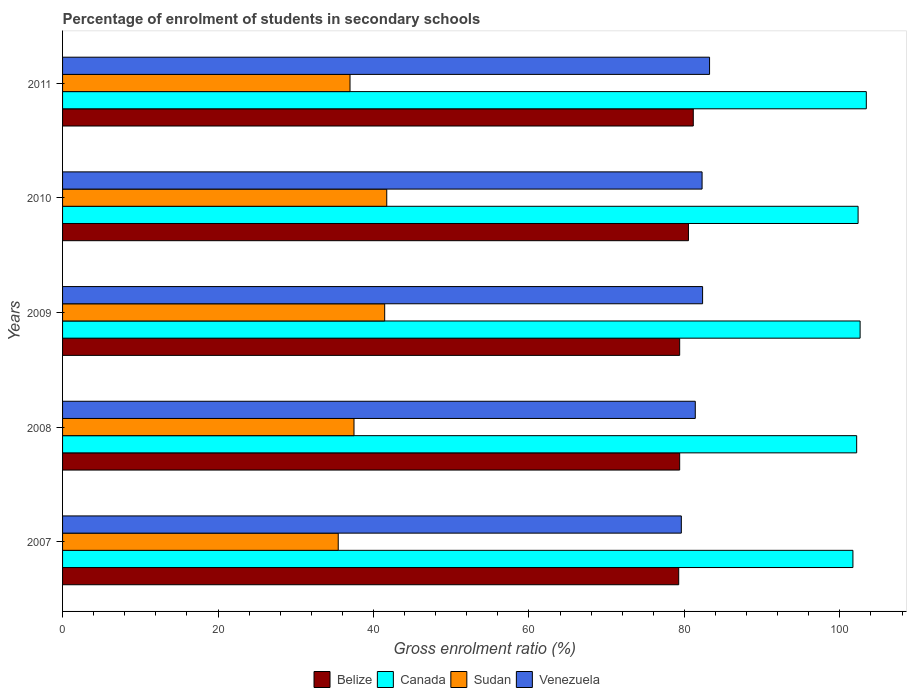How many different coloured bars are there?
Make the answer very short. 4. How many groups of bars are there?
Provide a succinct answer. 5. Are the number of bars per tick equal to the number of legend labels?
Offer a terse response. Yes. How many bars are there on the 1st tick from the top?
Your answer should be compact. 4. In how many cases, is the number of bars for a given year not equal to the number of legend labels?
Your answer should be compact. 0. What is the percentage of students enrolled in secondary schools in Belize in 2011?
Make the answer very short. 81.14. Across all years, what is the maximum percentage of students enrolled in secondary schools in Venezuela?
Your answer should be compact. 83.24. Across all years, what is the minimum percentage of students enrolled in secondary schools in Belize?
Your answer should be very brief. 79.27. In which year was the percentage of students enrolled in secondary schools in Sudan minimum?
Your answer should be very brief. 2007. What is the total percentage of students enrolled in secondary schools in Canada in the graph?
Your answer should be compact. 512.21. What is the difference between the percentage of students enrolled in secondary schools in Belize in 2009 and that in 2011?
Make the answer very short. -1.75. What is the difference between the percentage of students enrolled in secondary schools in Canada in 2010 and the percentage of students enrolled in secondary schools in Venezuela in 2008?
Offer a terse response. 20.95. What is the average percentage of students enrolled in secondary schools in Venezuela per year?
Your answer should be very brief. 81.77. In the year 2009, what is the difference between the percentage of students enrolled in secondary schools in Venezuela and percentage of students enrolled in secondary schools in Canada?
Keep it short and to the point. -20.27. In how many years, is the percentage of students enrolled in secondary schools in Canada greater than 56 %?
Offer a very short reply. 5. What is the ratio of the percentage of students enrolled in secondary schools in Venezuela in 2007 to that in 2008?
Keep it short and to the point. 0.98. Is the difference between the percentage of students enrolled in secondary schools in Venezuela in 2007 and 2009 greater than the difference between the percentage of students enrolled in secondary schools in Canada in 2007 and 2009?
Offer a very short reply. No. What is the difference between the highest and the second highest percentage of students enrolled in secondary schools in Venezuela?
Make the answer very short. 0.9. What is the difference between the highest and the lowest percentage of students enrolled in secondary schools in Sudan?
Give a very brief answer. 6.24. What does the 2nd bar from the top in 2010 represents?
Offer a very short reply. Sudan. What does the 1st bar from the bottom in 2011 represents?
Your answer should be very brief. Belize. Is it the case that in every year, the sum of the percentage of students enrolled in secondary schools in Canada and percentage of students enrolled in secondary schools in Sudan is greater than the percentage of students enrolled in secondary schools in Venezuela?
Keep it short and to the point. Yes. Are all the bars in the graph horizontal?
Give a very brief answer. Yes. How many years are there in the graph?
Provide a succinct answer. 5. Are the values on the major ticks of X-axis written in scientific E-notation?
Offer a terse response. No. Where does the legend appear in the graph?
Your answer should be compact. Bottom center. How many legend labels are there?
Your answer should be very brief. 4. How are the legend labels stacked?
Your response must be concise. Horizontal. What is the title of the graph?
Your response must be concise. Percentage of enrolment of students in secondary schools. What is the label or title of the X-axis?
Your response must be concise. Gross enrolment ratio (%). What is the Gross enrolment ratio (%) in Belize in 2007?
Your answer should be compact. 79.27. What is the Gross enrolment ratio (%) in Canada in 2007?
Your answer should be very brief. 101.68. What is the Gross enrolment ratio (%) in Sudan in 2007?
Your answer should be very brief. 35.47. What is the Gross enrolment ratio (%) of Venezuela in 2007?
Make the answer very short. 79.61. What is the Gross enrolment ratio (%) in Belize in 2008?
Give a very brief answer. 79.39. What is the Gross enrolment ratio (%) in Canada in 2008?
Give a very brief answer. 102.16. What is the Gross enrolment ratio (%) in Sudan in 2008?
Your response must be concise. 37.49. What is the Gross enrolment ratio (%) of Venezuela in 2008?
Your answer should be very brief. 81.4. What is the Gross enrolment ratio (%) of Belize in 2009?
Make the answer very short. 79.39. What is the Gross enrolment ratio (%) in Canada in 2009?
Provide a short and direct response. 102.61. What is the Gross enrolment ratio (%) in Sudan in 2009?
Provide a short and direct response. 41.44. What is the Gross enrolment ratio (%) in Venezuela in 2009?
Offer a very short reply. 82.34. What is the Gross enrolment ratio (%) in Belize in 2010?
Offer a very short reply. 80.52. What is the Gross enrolment ratio (%) in Canada in 2010?
Ensure brevity in your answer.  102.35. What is the Gross enrolment ratio (%) in Sudan in 2010?
Ensure brevity in your answer.  41.71. What is the Gross enrolment ratio (%) in Venezuela in 2010?
Provide a succinct answer. 82.28. What is the Gross enrolment ratio (%) of Belize in 2011?
Provide a short and direct response. 81.14. What is the Gross enrolment ratio (%) in Canada in 2011?
Ensure brevity in your answer.  103.4. What is the Gross enrolment ratio (%) in Sudan in 2011?
Provide a short and direct response. 36.98. What is the Gross enrolment ratio (%) in Venezuela in 2011?
Your answer should be very brief. 83.24. Across all years, what is the maximum Gross enrolment ratio (%) of Belize?
Offer a very short reply. 81.14. Across all years, what is the maximum Gross enrolment ratio (%) of Canada?
Offer a terse response. 103.4. Across all years, what is the maximum Gross enrolment ratio (%) of Sudan?
Your response must be concise. 41.71. Across all years, what is the maximum Gross enrolment ratio (%) of Venezuela?
Your answer should be very brief. 83.24. Across all years, what is the minimum Gross enrolment ratio (%) in Belize?
Provide a succinct answer. 79.27. Across all years, what is the minimum Gross enrolment ratio (%) of Canada?
Provide a succinct answer. 101.68. Across all years, what is the minimum Gross enrolment ratio (%) in Sudan?
Provide a short and direct response. 35.47. Across all years, what is the minimum Gross enrolment ratio (%) in Venezuela?
Give a very brief answer. 79.61. What is the total Gross enrolment ratio (%) of Belize in the graph?
Ensure brevity in your answer.  399.72. What is the total Gross enrolment ratio (%) in Canada in the graph?
Provide a succinct answer. 512.21. What is the total Gross enrolment ratio (%) of Sudan in the graph?
Your answer should be very brief. 193.09. What is the total Gross enrolment ratio (%) in Venezuela in the graph?
Offer a very short reply. 408.86. What is the difference between the Gross enrolment ratio (%) of Belize in 2007 and that in 2008?
Make the answer very short. -0.12. What is the difference between the Gross enrolment ratio (%) in Canada in 2007 and that in 2008?
Provide a succinct answer. -0.48. What is the difference between the Gross enrolment ratio (%) of Sudan in 2007 and that in 2008?
Your answer should be very brief. -2.03. What is the difference between the Gross enrolment ratio (%) of Venezuela in 2007 and that in 2008?
Offer a terse response. -1.8. What is the difference between the Gross enrolment ratio (%) in Belize in 2007 and that in 2009?
Keep it short and to the point. -0.12. What is the difference between the Gross enrolment ratio (%) of Canada in 2007 and that in 2009?
Offer a terse response. -0.93. What is the difference between the Gross enrolment ratio (%) of Sudan in 2007 and that in 2009?
Ensure brevity in your answer.  -5.98. What is the difference between the Gross enrolment ratio (%) of Venezuela in 2007 and that in 2009?
Offer a very short reply. -2.74. What is the difference between the Gross enrolment ratio (%) of Belize in 2007 and that in 2010?
Your answer should be compact. -1.25. What is the difference between the Gross enrolment ratio (%) of Canada in 2007 and that in 2010?
Your answer should be compact. -0.67. What is the difference between the Gross enrolment ratio (%) of Sudan in 2007 and that in 2010?
Give a very brief answer. -6.24. What is the difference between the Gross enrolment ratio (%) of Venezuela in 2007 and that in 2010?
Your response must be concise. -2.67. What is the difference between the Gross enrolment ratio (%) in Belize in 2007 and that in 2011?
Your response must be concise. -1.88. What is the difference between the Gross enrolment ratio (%) in Canada in 2007 and that in 2011?
Offer a terse response. -1.72. What is the difference between the Gross enrolment ratio (%) of Sudan in 2007 and that in 2011?
Provide a short and direct response. -1.52. What is the difference between the Gross enrolment ratio (%) in Venezuela in 2007 and that in 2011?
Your answer should be compact. -3.63. What is the difference between the Gross enrolment ratio (%) in Belize in 2008 and that in 2009?
Ensure brevity in your answer.  0. What is the difference between the Gross enrolment ratio (%) in Canada in 2008 and that in 2009?
Give a very brief answer. -0.44. What is the difference between the Gross enrolment ratio (%) in Sudan in 2008 and that in 2009?
Offer a terse response. -3.95. What is the difference between the Gross enrolment ratio (%) of Venezuela in 2008 and that in 2009?
Provide a short and direct response. -0.94. What is the difference between the Gross enrolment ratio (%) of Belize in 2008 and that in 2010?
Provide a succinct answer. -1.13. What is the difference between the Gross enrolment ratio (%) of Canada in 2008 and that in 2010?
Provide a succinct answer. -0.18. What is the difference between the Gross enrolment ratio (%) in Sudan in 2008 and that in 2010?
Provide a short and direct response. -4.21. What is the difference between the Gross enrolment ratio (%) in Venezuela in 2008 and that in 2010?
Your answer should be very brief. -0.87. What is the difference between the Gross enrolment ratio (%) in Belize in 2008 and that in 2011?
Ensure brevity in your answer.  -1.75. What is the difference between the Gross enrolment ratio (%) of Canada in 2008 and that in 2011?
Your response must be concise. -1.24. What is the difference between the Gross enrolment ratio (%) of Sudan in 2008 and that in 2011?
Your answer should be compact. 0.51. What is the difference between the Gross enrolment ratio (%) of Venezuela in 2008 and that in 2011?
Provide a succinct answer. -1.84. What is the difference between the Gross enrolment ratio (%) in Belize in 2009 and that in 2010?
Your answer should be very brief. -1.13. What is the difference between the Gross enrolment ratio (%) of Canada in 2009 and that in 2010?
Your answer should be compact. 0.26. What is the difference between the Gross enrolment ratio (%) in Sudan in 2009 and that in 2010?
Provide a short and direct response. -0.27. What is the difference between the Gross enrolment ratio (%) of Venezuela in 2009 and that in 2010?
Keep it short and to the point. 0.07. What is the difference between the Gross enrolment ratio (%) in Belize in 2009 and that in 2011?
Your answer should be compact. -1.75. What is the difference between the Gross enrolment ratio (%) of Canada in 2009 and that in 2011?
Ensure brevity in your answer.  -0.8. What is the difference between the Gross enrolment ratio (%) of Sudan in 2009 and that in 2011?
Give a very brief answer. 4.46. What is the difference between the Gross enrolment ratio (%) in Venezuela in 2009 and that in 2011?
Provide a succinct answer. -0.9. What is the difference between the Gross enrolment ratio (%) of Belize in 2010 and that in 2011?
Offer a very short reply. -0.62. What is the difference between the Gross enrolment ratio (%) of Canada in 2010 and that in 2011?
Offer a very short reply. -1.06. What is the difference between the Gross enrolment ratio (%) in Sudan in 2010 and that in 2011?
Give a very brief answer. 4.73. What is the difference between the Gross enrolment ratio (%) in Venezuela in 2010 and that in 2011?
Offer a terse response. -0.96. What is the difference between the Gross enrolment ratio (%) in Belize in 2007 and the Gross enrolment ratio (%) in Canada in 2008?
Make the answer very short. -22.9. What is the difference between the Gross enrolment ratio (%) of Belize in 2007 and the Gross enrolment ratio (%) of Sudan in 2008?
Your answer should be compact. 41.77. What is the difference between the Gross enrolment ratio (%) of Belize in 2007 and the Gross enrolment ratio (%) of Venezuela in 2008?
Offer a terse response. -2.13. What is the difference between the Gross enrolment ratio (%) in Canada in 2007 and the Gross enrolment ratio (%) in Sudan in 2008?
Give a very brief answer. 64.19. What is the difference between the Gross enrolment ratio (%) in Canada in 2007 and the Gross enrolment ratio (%) in Venezuela in 2008?
Your answer should be very brief. 20.28. What is the difference between the Gross enrolment ratio (%) of Sudan in 2007 and the Gross enrolment ratio (%) of Venezuela in 2008?
Ensure brevity in your answer.  -45.94. What is the difference between the Gross enrolment ratio (%) in Belize in 2007 and the Gross enrolment ratio (%) in Canada in 2009?
Offer a terse response. -23.34. What is the difference between the Gross enrolment ratio (%) in Belize in 2007 and the Gross enrolment ratio (%) in Sudan in 2009?
Keep it short and to the point. 37.83. What is the difference between the Gross enrolment ratio (%) of Belize in 2007 and the Gross enrolment ratio (%) of Venezuela in 2009?
Provide a short and direct response. -3.07. What is the difference between the Gross enrolment ratio (%) in Canada in 2007 and the Gross enrolment ratio (%) in Sudan in 2009?
Your answer should be compact. 60.24. What is the difference between the Gross enrolment ratio (%) of Canada in 2007 and the Gross enrolment ratio (%) of Venezuela in 2009?
Offer a very short reply. 19.34. What is the difference between the Gross enrolment ratio (%) of Sudan in 2007 and the Gross enrolment ratio (%) of Venezuela in 2009?
Your response must be concise. -46.88. What is the difference between the Gross enrolment ratio (%) in Belize in 2007 and the Gross enrolment ratio (%) in Canada in 2010?
Make the answer very short. -23.08. What is the difference between the Gross enrolment ratio (%) of Belize in 2007 and the Gross enrolment ratio (%) of Sudan in 2010?
Your response must be concise. 37.56. What is the difference between the Gross enrolment ratio (%) in Belize in 2007 and the Gross enrolment ratio (%) in Venezuela in 2010?
Your answer should be very brief. -3.01. What is the difference between the Gross enrolment ratio (%) in Canada in 2007 and the Gross enrolment ratio (%) in Sudan in 2010?
Your answer should be very brief. 59.97. What is the difference between the Gross enrolment ratio (%) in Canada in 2007 and the Gross enrolment ratio (%) in Venezuela in 2010?
Offer a very short reply. 19.41. What is the difference between the Gross enrolment ratio (%) of Sudan in 2007 and the Gross enrolment ratio (%) of Venezuela in 2010?
Your response must be concise. -46.81. What is the difference between the Gross enrolment ratio (%) of Belize in 2007 and the Gross enrolment ratio (%) of Canada in 2011?
Offer a terse response. -24.14. What is the difference between the Gross enrolment ratio (%) of Belize in 2007 and the Gross enrolment ratio (%) of Sudan in 2011?
Give a very brief answer. 42.29. What is the difference between the Gross enrolment ratio (%) of Belize in 2007 and the Gross enrolment ratio (%) of Venezuela in 2011?
Ensure brevity in your answer.  -3.97. What is the difference between the Gross enrolment ratio (%) of Canada in 2007 and the Gross enrolment ratio (%) of Sudan in 2011?
Offer a terse response. 64.7. What is the difference between the Gross enrolment ratio (%) of Canada in 2007 and the Gross enrolment ratio (%) of Venezuela in 2011?
Give a very brief answer. 18.44. What is the difference between the Gross enrolment ratio (%) of Sudan in 2007 and the Gross enrolment ratio (%) of Venezuela in 2011?
Offer a terse response. -47.77. What is the difference between the Gross enrolment ratio (%) of Belize in 2008 and the Gross enrolment ratio (%) of Canada in 2009?
Your response must be concise. -23.21. What is the difference between the Gross enrolment ratio (%) of Belize in 2008 and the Gross enrolment ratio (%) of Sudan in 2009?
Ensure brevity in your answer.  37.95. What is the difference between the Gross enrolment ratio (%) of Belize in 2008 and the Gross enrolment ratio (%) of Venezuela in 2009?
Offer a very short reply. -2.95. What is the difference between the Gross enrolment ratio (%) in Canada in 2008 and the Gross enrolment ratio (%) in Sudan in 2009?
Your answer should be very brief. 60.72. What is the difference between the Gross enrolment ratio (%) of Canada in 2008 and the Gross enrolment ratio (%) of Venezuela in 2009?
Your response must be concise. 19.82. What is the difference between the Gross enrolment ratio (%) in Sudan in 2008 and the Gross enrolment ratio (%) in Venezuela in 2009?
Give a very brief answer. -44.85. What is the difference between the Gross enrolment ratio (%) in Belize in 2008 and the Gross enrolment ratio (%) in Canada in 2010?
Your response must be concise. -22.95. What is the difference between the Gross enrolment ratio (%) in Belize in 2008 and the Gross enrolment ratio (%) in Sudan in 2010?
Give a very brief answer. 37.69. What is the difference between the Gross enrolment ratio (%) in Belize in 2008 and the Gross enrolment ratio (%) in Venezuela in 2010?
Your answer should be compact. -2.88. What is the difference between the Gross enrolment ratio (%) of Canada in 2008 and the Gross enrolment ratio (%) of Sudan in 2010?
Give a very brief answer. 60.46. What is the difference between the Gross enrolment ratio (%) in Canada in 2008 and the Gross enrolment ratio (%) in Venezuela in 2010?
Your response must be concise. 19.89. What is the difference between the Gross enrolment ratio (%) in Sudan in 2008 and the Gross enrolment ratio (%) in Venezuela in 2010?
Your response must be concise. -44.78. What is the difference between the Gross enrolment ratio (%) of Belize in 2008 and the Gross enrolment ratio (%) of Canada in 2011?
Offer a terse response. -24.01. What is the difference between the Gross enrolment ratio (%) of Belize in 2008 and the Gross enrolment ratio (%) of Sudan in 2011?
Your answer should be compact. 42.41. What is the difference between the Gross enrolment ratio (%) of Belize in 2008 and the Gross enrolment ratio (%) of Venezuela in 2011?
Provide a short and direct response. -3.84. What is the difference between the Gross enrolment ratio (%) in Canada in 2008 and the Gross enrolment ratio (%) in Sudan in 2011?
Your answer should be very brief. 65.18. What is the difference between the Gross enrolment ratio (%) in Canada in 2008 and the Gross enrolment ratio (%) in Venezuela in 2011?
Provide a succinct answer. 18.93. What is the difference between the Gross enrolment ratio (%) of Sudan in 2008 and the Gross enrolment ratio (%) of Venezuela in 2011?
Keep it short and to the point. -45.74. What is the difference between the Gross enrolment ratio (%) of Belize in 2009 and the Gross enrolment ratio (%) of Canada in 2010?
Make the answer very short. -22.95. What is the difference between the Gross enrolment ratio (%) in Belize in 2009 and the Gross enrolment ratio (%) in Sudan in 2010?
Make the answer very short. 37.69. What is the difference between the Gross enrolment ratio (%) in Belize in 2009 and the Gross enrolment ratio (%) in Venezuela in 2010?
Give a very brief answer. -2.88. What is the difference between the Gross enrolment ratio (%) in Canada in 2009 and the Gross enrolment ratio (%) in Sudan in 2010?
Your answer should be very brief. 60.9. What is the difference between the Gross enrolment ratio (%) in Canada in 2009 and the Gross enrolment ratio (%) in Venezuela in 2010?
Your answer should be very brief. 20.33. What is the difference between the Gross enrolment ratio (%) of Sudan in 2009 and the Gross enrolment ratio (%) of Venezuela in 2010?
Provide a short and direct response. -40.83. What is the difference between the Gross enrolment ratio (%) of Belize in 2009 and the Gross enrolment ratio (%) of Canada in 2011?
Keep it short and to the point. -24.01. What is the difference between the Gross enrolment ratio (%) in Belize in 2009 and the Gross enrolment ratio (%) in Sudan in 2011?
Your answer should be compact. 42.41. What is the difference between the Gross enrolment ratio (%) of Belize in 2009 and the Gross enrolment ratio (%) of Venezuela in 2011?
Ensure brevity in your answer.  -3.85. What is the difference between the Gross enrolment ratio (%) in Canada in 2009 and the Gross enrolment ratio (%) in Sudan in 2011?
Your answer should be compact. 65.63. What is the difference between the Gross enrolment ratio (%) of Canada in 2009 and the Gross enrolment ratio (%) of Venezuela in 2011?
Keep it short and to the point. 19.37. What is the difference between the Gross enrolment ratio (%) of Sudan in 2009 and the Gross enrolment ratio (%) of Venezuela in 2011?
Provide a succinct answer. -41.8. What is the difference between the Gross enrolment ratio (%) in Belize in 2010 and the Gross enrolment ratio (%) in Canada in 2011?
Offer a terse response. -22.88. What is the difference between the Gross enrolment ratio (%) of Belize in 2010 and the Gross enrolment ratio (%) of Sudan in 2011?
Offer a terse response. 43.54. What is the difference between the Gross enrolment ratio (%) of Belize in 2010 and the Gross enrolment ratio (%) of Venezuela in 2011?
Your response must be concise. -2.72. What is the difference between the Gross enrolment ratio (%) in Canada in 2010 and the Gross enrolment ratio (%) in Sudan in 2011?
Keep it short and to the point. 65.37. What is the difference between the Gross enrolment ratio (%) in Canada in 2010 and the Gross enrolment ratio (%) in Venezuela in 2011?
Ensure brevity in your answer.  19.11. What is the difference between the Gross enrolment ratio (%) of Sudan in 2010 and the Gross enrolment ratio (%) of Venezuela in 2011?
Provide a succinct answer. -41.53. What is the average Gross enrolment ratio (%) in Belize per year?
Keep it short and to the point. 79.94. What is the average Gross enrolment ratio (%) in Canada per year?
Provide a succinct answer. 102.44. What is the average Gross enrolment ratio (%) of Sudan per year?
Keep it short and to the point. 38.62. What is the average Gross enrolment ratio (%) of Venezuela per year?
Offer a very short reply. 81.77. In the year 2007, what is the difference between the Gross enrolment ratio (%) of Belize and Gross enrolment ratio (%) of Canada?
Give a very brief answer. -22.41. In the year 2007, what is the difference between the Gross enrolment ratio (%) in Belize and Gross enrolment ratio (%) in Sudan?
Your response must be concise. 43.8. In the year 2007, what is the difference between the Gross enrolment ratio (%) in Belize and Gross enrolment ratio (%) in Venezuela?
Your answer should be compact. -0.34. In the year 2007, what is the difference between the Gross enrolment ratio (%) of Canada and Gross enrolment ratio (%) of Sudan?
Your response must be concise. 66.22. In the year 2007, what is the difference between the Gross enrolment ratio (%) of Canada and Gross enrolment ratio (%) of Venezuela?
Keep it short and to the point. 22.08. In the year 2007, what is the difference between the Gross enrolment ratio (%) in Sudan and Gross enrolment ratio (%) in Venezuela?
Your answer should be compact. -44.14. In the year 2008, what is the difference between the Gross enrolment ratio (%) of Belize and Gross enrolment ratio (%) of Canada?
Your answer should be very brief. -22.77. In the year 2008, what is the difference between the Gross enrolment ratio (%) of Belize and Gross enrolment ratio (%) of Sudan?
Offer a very short reply. 41.9. In the year 2008, what is the difference between the Gross enrolment ratio (%) of Belize and Gross enrolment ratio (%) of Venezuela?
Offer a terse response. -2.01. In the year 2008, what is the difference between the Gross enrolment ratio (%) of Canada and Gross enrolment ratio (%) of Sudan?
Keep it short and to the point. 64.67. In the year 2008, what is the difference between the Gross enrolment ratio (%) in Canada and Gross enrolment ratio (%) in Venezuela?
Give a very brief answer. 20.76. In the year 2008, what is the difference between the Gross enrolment ratio (%) in Sudan and Gross enrolment ratio (%) in Venezuela?
Offer a very short reply. -43.91. In the year 2009, what is the difference between the Gross enrolment ratio (%) in Belize and Gross enrolment ratio (%) in Canada?
Your answer should be compact. -23.21. In the year 2009, what is the difference between the Gross enrolment ratio (%) of Belize and Gross enrolment ratio (%) of Sudan?
Offer a terse response. 37.95. In the year 2009, what is the difference between the Gross enrolment ratio (%) of Belize and Gross enrolment ratio (%) of Venezuela?
Keep it short and to the point. -2.95. In the year 2009, what is the difference between the Gross enrolment ratio (%) in Canada and Gross enrolment ratio (%) in Sudan?
Offer a very short reply. 61.17. In the year 2009, what is the difference between the Gross enrolment ratio (%) in Canada and Gross enrolment ratio (%) in Venezuela?
Provide a short and direct response. 20.27. In the year 2009, what is the difference between the Gross enrolment ratio (%) of Sudan and Gross enrolment ratio (%) of Venezuela?
Provide a short and direct response. -40.9. In the year 2010, what is the difference between the Gross enrolment ratio (%) of Belize and Gross enrolment ratio (%) of Canada?
Your answer should be very brief. -21.83. In the year 2010, what is the difference between the Gross enrolment ratio (%) of Belize and Gross enrolment ratio (%) of Sudan?
Provide a succinct answer. 38.81. In the year 2010, what is the difference between the Gross enrolment ratio (%) in Belize and Gross enrolment ratio (%) in Venezuela?
Provide a succinct answer. -1.75. In the year 2010, what is the difference between the Gross enrolment ratio (%) of Canada and Gross enrolment ratio (%) of Sudan?
Make the answer very short. 60.64. In the year 2010, what is the difference between the Gross enrolment ratio (%) in Canada and Gross enrolment ratio (%) in Venezuela?
Your answer should be compact. 20.07. In the year 2010, what is the difference between the Gross enrolment ratio (%) of Sudan and Gross enrolment ratio (%) of Venezuela?
Offer a terse response. -40.57. In the year 2011, what is the difference between the Gross enrolment ratio (%) of Belize and Gross enrolment ratio (%) of Canada?
Your answer should be very brief. -22.26. In the year 2011, what is the difference between the Gross enrolment ratio (%) of Belize and Gross enrolment ratio (%) of Sudan?
Your answer should be very brief. 44.16. In the year 2011, what is the difference between the Gross enrolment ratio (%) of Belize and Gross enrolment ratio (%) of Venezuela?
Provide a short and direct response. -2.09. In the year 2011, what is the difference between the Gross enrolment ratio (%) of Canada and Gross enrolment ratio (%) of Sudan?
Offer a terse response. 66.42. In the year 2011, what is the difference between the Gross enrolment ratio (%) of Canada and Gross enrolment ratio (%) of Venezuela?
Your answer should be compact. 20.17. In the year 2011, what is the difference between the Gross enrolment ratio (%) of Sudan and Gross enrolment ratio (%) of Venezuela?
Keep it short and to the point. -46.26. What is the ratio of the Gross enrolment ratio (%) of Sudan in 2007 to that in 2008?
Your answer should be very brief. 0.95. What is the ratio of the Gross enrolment ratio (%) of Venezuela in 2007 to that in 2008?
Give a very brief answer. 0.98. What is the ratio of the Gross enrolment ratio (%) in Belize in 2007 to that in 2009?
Provide a succinct answer. 1. What is the ratio of the Gross enrolment ratio (%) in Sudan in 2007 to that in 2009?
Ensure brevity in your answer.  0.86. What is the ratio of the Gross enrolment ratio (%) in Venezuela in 2007 to that in 2009?
Provide a succinct answer. 0.97. What is the ratio of the Gross enrolment ratio (%) of Belize in 2007 to that in 2010?
Provide a succinct answer. 0.98. What is the ratio of the Gross enrolment ratio (%) in Canada in 2007 to that in 2010?
Ensure brevity in your answer.  0.99. What is the ratio of the Gross enrolment ratio (%) of Sudan in 2007 to that in 2010?
Keep it short and to the point. 0.85. What is the ratio of the Gross enrolment ratio (%) of Venezuela in 2007 to that in 2010?
Ensure brevity in your answer.  0.97. What is the ratio of the Gross enrolment ratio (%) in Belize in 2007 to that in 2011?
Your response must be concise. 0.98. What is the ratio of the Gross enrolment ratio (%) in Canada in 2007 to that in 2011?
Your response must be concise. 0.98. What is the ratio of the Gross enrolment ratio (%) in Sudan in 2007 to that in 2011?
Keep it short and to the point. 0.96. What is the ratio of the Gross enrolment ratio (%) in Venezuela in 2007 to that in 2011?
Give a very brief answer. 0.96. What is the ratio of the Gross enrolment ratio (%) of Belize in 2008 to that in 2009?
Make the answer very short. 1. What is the ratio of the Gross enrolment ratio (%) of Sudan in 2008 to that in 2009?
Provide a short and direct response. 0.9. What is the ratio of the Gross enrolment ratio (%) in Belize in 2008 to that in 2010?
Provide a short and direct response. 0.99. What is the ratio of the Gross enrolment ratio (%) of Sudan in 2008 to that in 2010?
Your answer should be compact. 0.9. What is the ratio of the Gross enrolment ratio (%) of Venezuela in 2008 to that in 2010?
Your response must be concise. 0.99. What is the ratio of the Gross enrolment ratio (%) in Belize in 2008 to that in 2011?
Your response must be concise. 0.98. What is the ratio of the Gross enrolment ratio (%) in Canada in 2008 to that in 2011?
Your answer should be very brief. 0.99. What is the ratio of the Gross enrolment ratio (%) of Sudan in 2008 to that in 2011?
Your answer should be very brief. 1.01. What is the ratio of the Gross enrolment ratio (%) of Venezuela in 2008 to that in 2011?
Ensure brevity in your answer.  0.98. What is the ratio of the Gross enrolment ratio (%) in Belize in 2009 to that in 2010?
Ensure brevity in your answer.  0.99. What is the ratio of the Gross enrolment ratio (%) of Canada in 2009 to that in 2010?
Offer a terse response. 1. What is the ratio of the Gross enrolment ratio (%) of Venezuela in 2009 to that in 2010?
Offer a very short reply. 1. What is the ratio of the Gross enrolment ratio (%) in Belize in 2009 to that in 2011?
Give a very brief answer. 0.98. What is the ratio of the Gross enrolment ratio (%) in Canada in 2009 to that in 2011?
Offer a very short reply. 0.99. What is the ratio of the Gross enrolment ratio (%) of Sudan in 2009 to that in 2011?
Offer a terse response. 1.12. What is the ratio of the Gross enrolment ratio (%) of Canada in 2010 to that in 2011?
Ensure brevity in your answer.  0.99. What is the ratio of the Gross enrolment ratio (%) in Sudan in 2010 to that in 2011?
Offer a terse response. 1.13. What is the ratio of the Gross enrolment ratio (%) of Venezuela in 2010 to that in 2011?
Make the answer very short. 0.99. What is the difference between the highest and the second highest Gross enrolment ratio (%) of Belize?
Ensure brevity in your answer.  0.62. What is the difference between the highest and the second highest Gross enrolment ratio (%) in Canada?
Your answer should be very brief. 0.8. What is the difference between the highest and the second highest Gross enrolment ratio (%) of Sudan?
Your answer should be very brief. 0.27. What is the difference between the highest and the second highest Gross enrolment ratio (%) of Venezuela?
Ensure brevity in your answer.  0.9. What is the difference between the highest and the lowest Gross enrolment ratio (%) in Belize?
Provide a succinct answer. 1.88. What is the difference between the highest and the lowest Gross enrolment ratio (%) of Canada?
Offer a terse response. 1.72. What is the difference between the highest and the lowest Gross enrolment ratio (%) of Sudan?
Give a very brief answer. 6.24. What is the difference between the highest and the lowest Gross enrolment ratio (%) in Venezuela?
Ensure brevity in your answer.  3.63. 